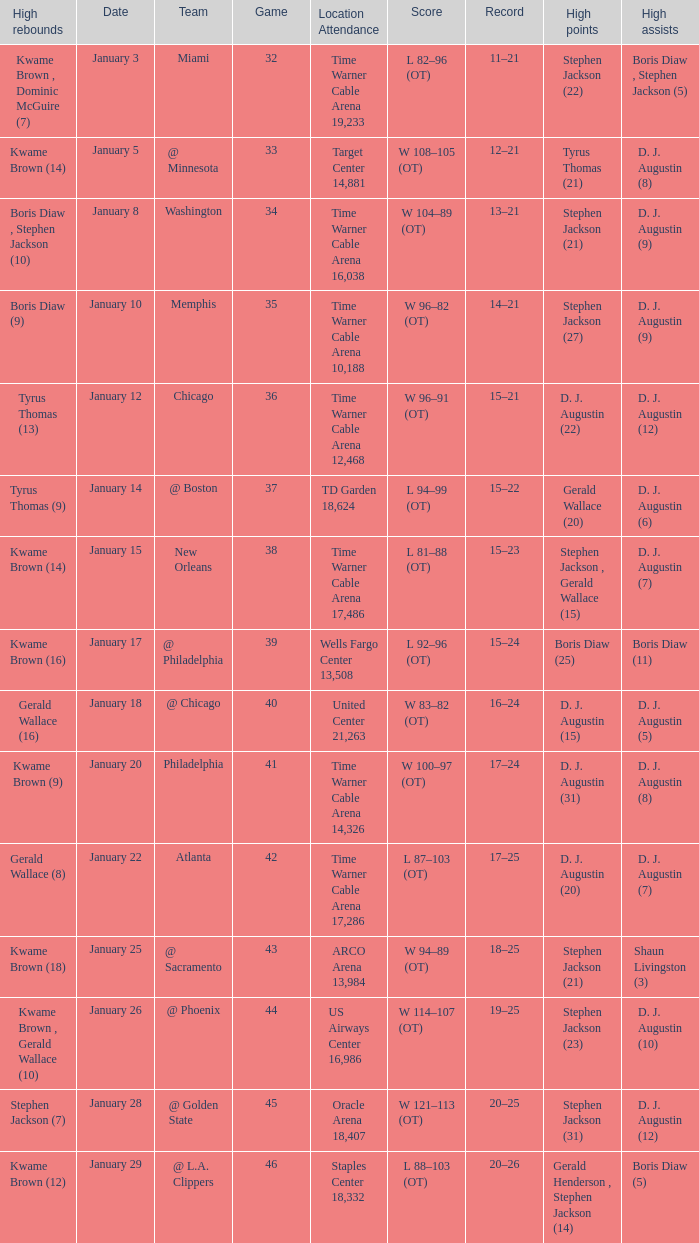How many high rebounds are listed for game 35? 1.0. 